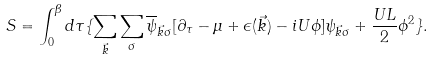Convert formula to latex. <formula><loc_0><loc_0><loc_500><loc_500>S = \int _ { 0 } ^ { \beta } d \tau \{ \sum _ { \vec { k } } \sum _ { \sigma } \overline { \psi } _ { \vec { k } \sigma } [ \partial _ { \tau } - \mu + \epsilon ( \vec { k } ) - i U \phi ] \psi _ { \vec { k } \sigma } + \frac { U L } { 2 } \phi ^ { 2 } \} .</formula> 